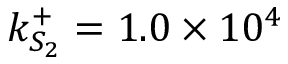<formula> <loc_0><loc_0><loc_500><loc_500>k _ { S _ { 2 } } ^ { + } = 1 . 0 \times 1 0 ^ { 4 }</formula> 